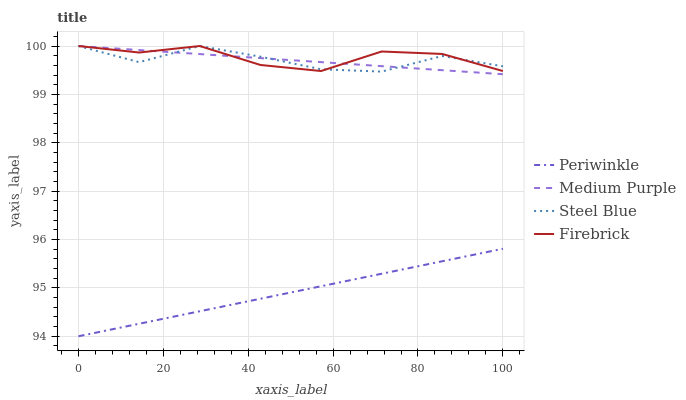Does Periwinkle have the minimum area under the curve?
Answer yes or no. Yes. Does Firebrick have the maximum area under the curve?
Answer yes or no. Yes. Does Firebrick have the minimum area under the curve?
Answer yes or no. No. Does Periwinkle have the maximum area under the curve?
Answer yes or no. No. Is Periwinkle the smoothest?
Answer yes or no. Yes. Is Steel Blue the roughest?
Answer yes or no. Yes. Is Firebrick the smoothest?
Answer yes or no. No. Is Firebrick the roughest?
Answer yes or no. No. Does Periwinkle have the lowest value?
Answer yes or no. Yes. Does Firebrick have the lowest value?
Answer yes or no. No. Does Steel Blue have the highest value?
Answer yes or no. Yes. Does Periwinkle have the highest value?
Answer yes or no. No. Is Periwinkle less than Firebrick?
Answer yes or no. Yes. Is Firebrick greater than Periwinkle?
Answer yes or no. Yes. Does Medium Purple intersect Firebrick?
Answer yes or no. Yes. Is Medium Purple less than Firebrick?
Answer yes or no. No. Is Medium Purple greater than Firebrick?
Answer yes or no. No. Does Periwinkle intersect Firebrick?
Answer yes or no. No. 